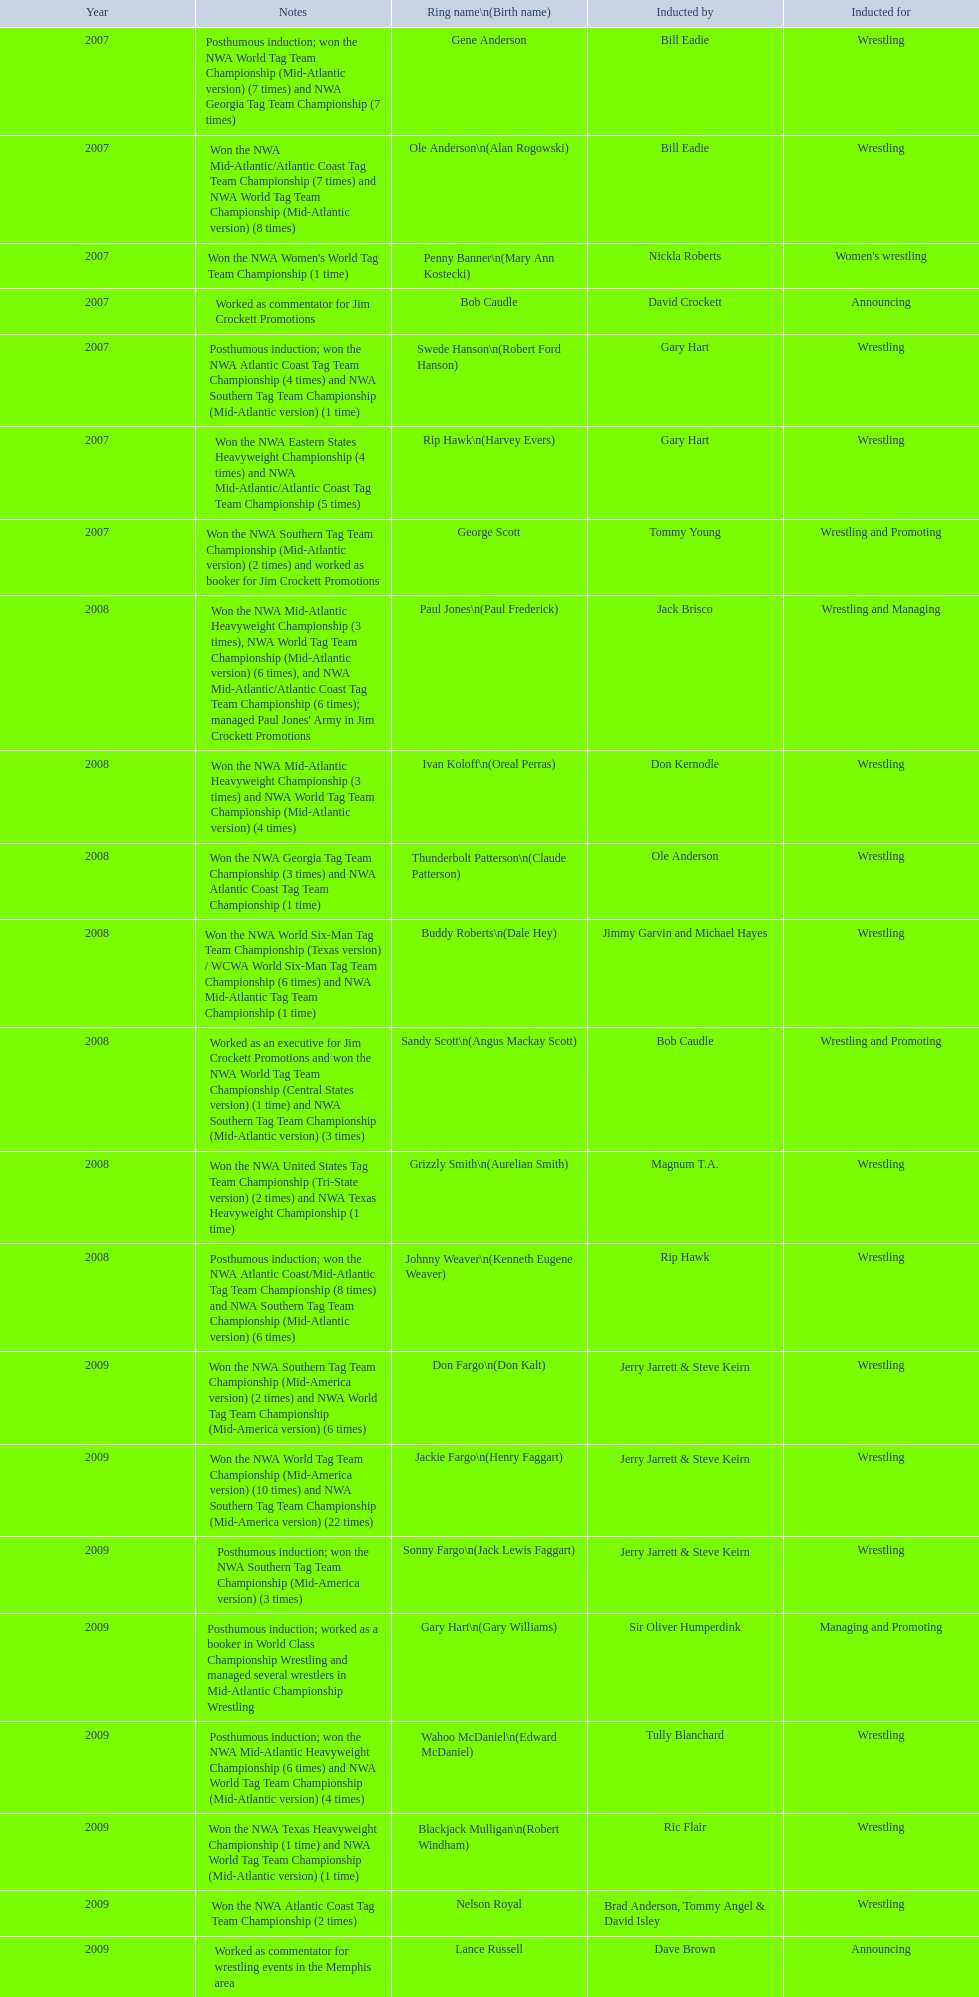What were all the wrestler's ring names? Gene Anderson, Ole Anderson\n(Alan Rogowski), Penny Banner\n(Mary Ann Kostecki), Bob Caudle, Swede Hanson\n(Robert Ford Hanson), Rip Hawk\n(Harvey Evers), George Scott, Paul Jones\n(Paul Frederick), Ivan Koloff\n(Oreal Perras), Thunderbolt Patterson\n(Claude Patterson), Buddy Roberts\n(Dale Hey), Sandy Scott\n(Angus Mackay Scott), Grizzly Smith\n(Aurelian Smith), Johnny Weaver\n(Kenneth Eugene Weaver), Don Fargo\n(Don Kalt), Jackie Fargo\n(Henry Faggart), Sonny Fargo\n(Jack Lewis Faggart), Gary Hart\n(Gary Williams), Wahoo McDaniel\n(Edward McDaniel), Blackjack Mulligan\n(Robert Windham), Nelson Royal, Lance Russell. Besides bob caudle, who was an announcer? Lance Russell. 